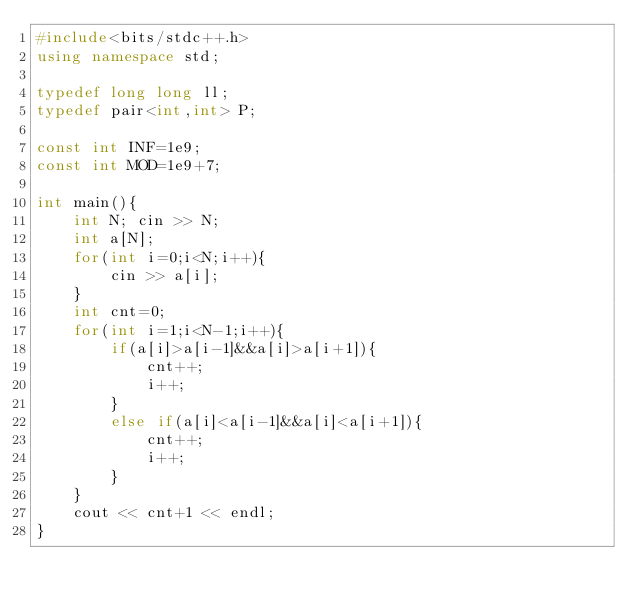<code> <loc_0><loc_0><loc_500><loc_500><_C++_>#include<bits/stdc++.h>
using namespace std;

typedef long long ll;
typedef pair<int,int> P;

const int INF=1e9;
const int MOD=1e9+7;

int main(){
    int N; cin >> N;
    int a[N];
    for(int i=0;i<N;i++){
        cin >> a[i];
    }
    int cnt=0;
    for(int i=1;i<N-1;i++){
        if(a[i]>a[i-1]&&a[i]>a[i+1]){
            cnt++;
            i++;
        }
        else if(a[i]<a[i-1]&&a[i]<a[i+1]){
            cnt++;
            i++;
        }
    }
    cout << cnt+1 << endl;
}</code> 